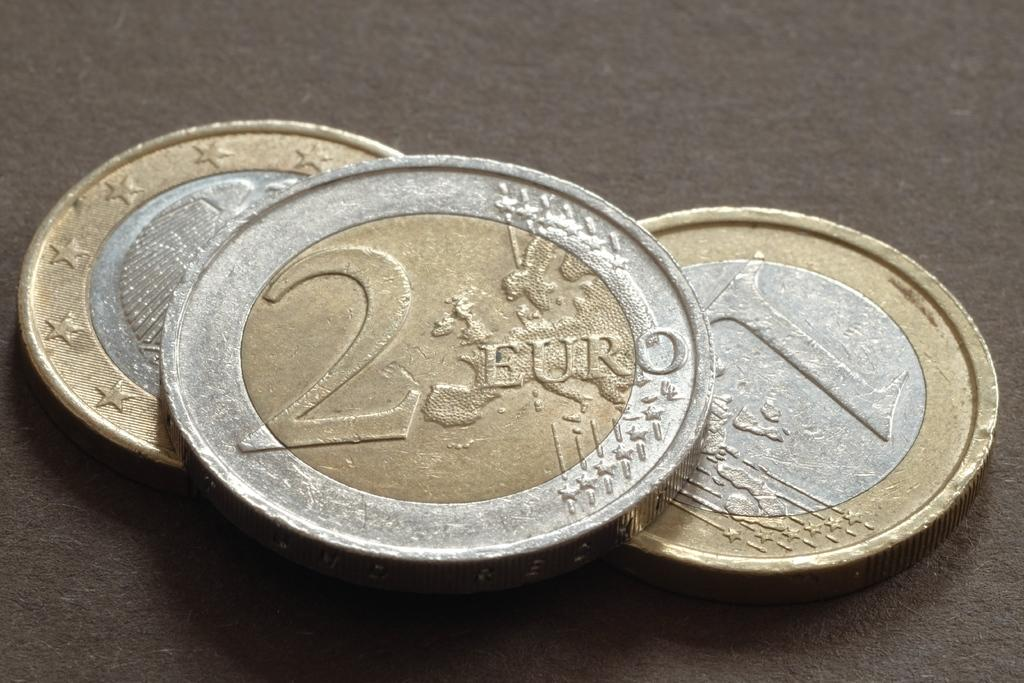<image>
Offer a succinct explanation of the picture presented. Three coins on a table and one saying 2 Euro. 